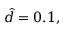Convert formula to latex. <formula><loc_0><loc_0><loc_500><loc_500>\hat { d } = 0 . 1 ,</formula> 